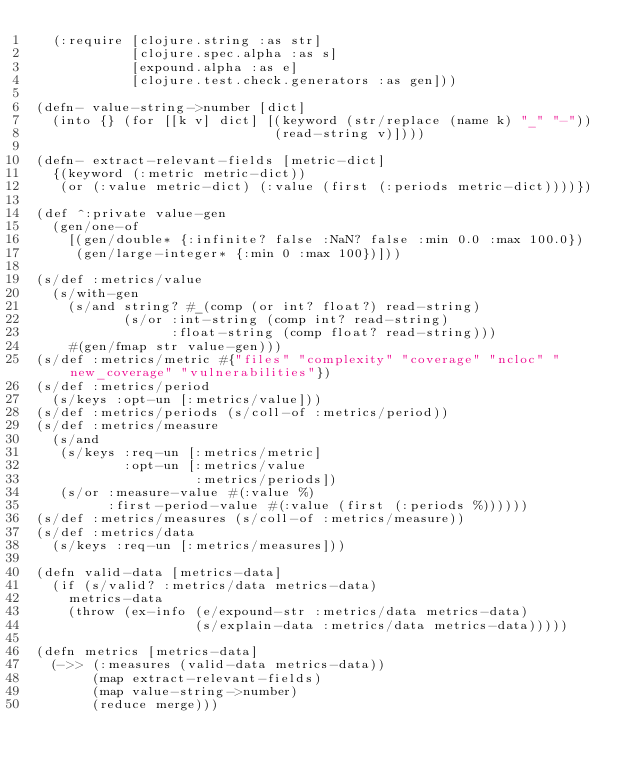Convert code to text. <code><loc_0><loc_0><loc_500><loc_500><_Clojure_>  (:require [clojure.string :as str]
            [clojure.spec.alpha :as s]
            [expound.alpha :as e]
            [clojure.test.check.generators :as gen]))

(defn- value-string->number [dict]
  (into {} (for [[k v] dict] [(keyword (str/replace (name k) "_" "-"))
                              (read-string v)])))

(defn- extract-relevant-fields [metric-dict]
  {(keyword (:metric metric-dict))
   (or (:value metric-dict) (:value (first (:periods metric-dict))))})

(def ^:private value-gen
  (gen/one-of
    [(gen/double* {:infinite? false :NaN? false :min 0.0 :max 100.0})
     (gen/large-integer* {:min 0 :max 100})]))

(s/def :metrics/value
  (s/with-gen
    (s/and string? #_(comp (or int? float?) read-string)
           (s/or :int-string (comp int? read-string)
                 :float-string (comp float? read-string)))
    #(gen/fmap str value-gen)))
(s/def :metrics/metric #{"files" "complexity" "coverage" "ncloc" "new_coverage" "vulnerabilities"})
(s/def :metrics/period
  (s/keys :opt-un [:metrics/value]))
(s/def :metrics/periods (s/coll-of :metrics/period))
(s/def :metrics/measure
  (s/and
   (s/keys :req-un [:metrics/metric]
           :opt-un [:metrics/value
                    :metrics/periods])
   (s/or :measure-value #(:value %)
         :first-period-value #(:value (first (:periods %))))))
(s/def :metrics/measures (s/coll-of :metrics/measure))
(s/def :metrics/data
  (s/keys :req-un [:metrics/measures]))

(defn valid-data [metrics-data]
  (if (s/valid? :metrics/data metrics-data)
    metrics-data
    (throw (ex-info (e/expound-str :metrics/data metrics-data)
                    (s/explain-data :metrics/data metrics-data)))))

(defn metrics [metrics-data]
  (->> (:measures (valid-data metrics-data))
       (map extract-relevant-fields)
       (map value-string->number)
       (reduce merge)))
</code> 